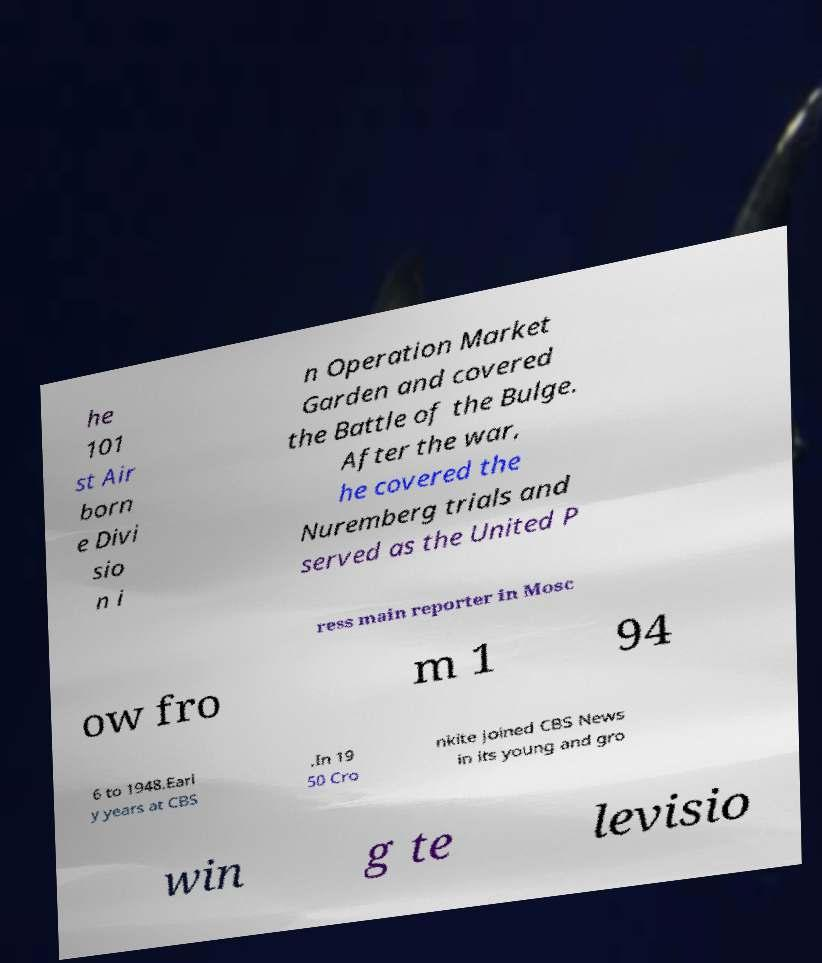Please identify and transcribe the text found in this image. he 101 st Air born e Divi sio n i n Operation Market Garden and covered the Battle of the Bulge. After the war, he covered the Nuremberg trials and served as the United P ress main reporter in Mosc ow fro m 1 94 6 to 1948.Earl y years at CBS .In 19 50 Cro nkite joined CBS News in its young and gro win g te levisio 